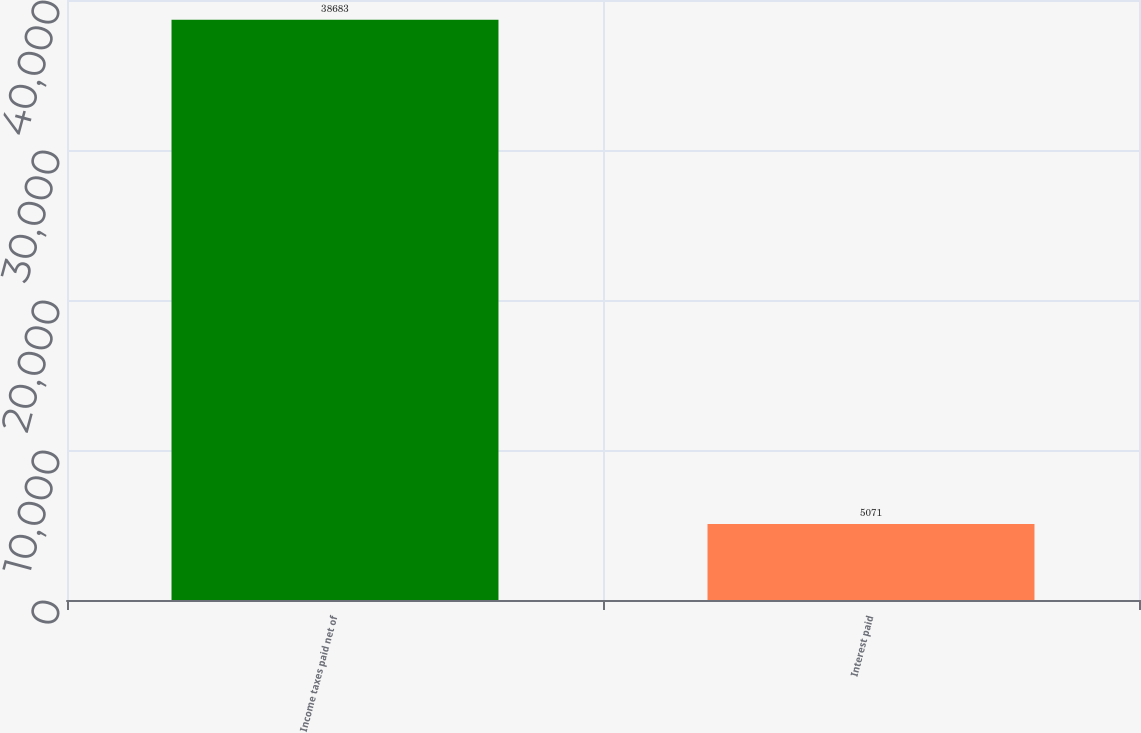Convert chart. <chart><loc_0><loc_0><loc_500><loc_500><bar_chart><fcel>Income taxes paid net of<fcel>Interest paid<nl><fcel>38683<fcel>5071<nl></chart> 